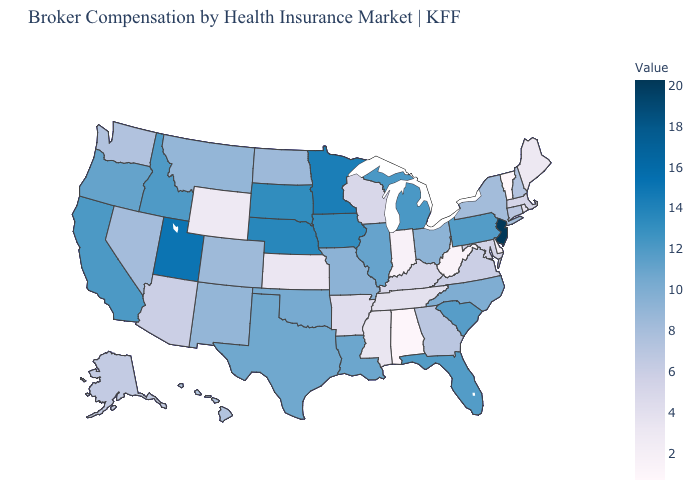Does Virginia have a lower value than Wyoming?
Concise answer only. No. Among the states that border Missouri , does Nebraska have the highest value?
Keep it brief. Yes. Among the states that border Texas , does Arkansas have the lowest value?
Be succinct. Yes. Among the states that border North Carolina , does Virginia have the highest value?
Quick response, please. No. 